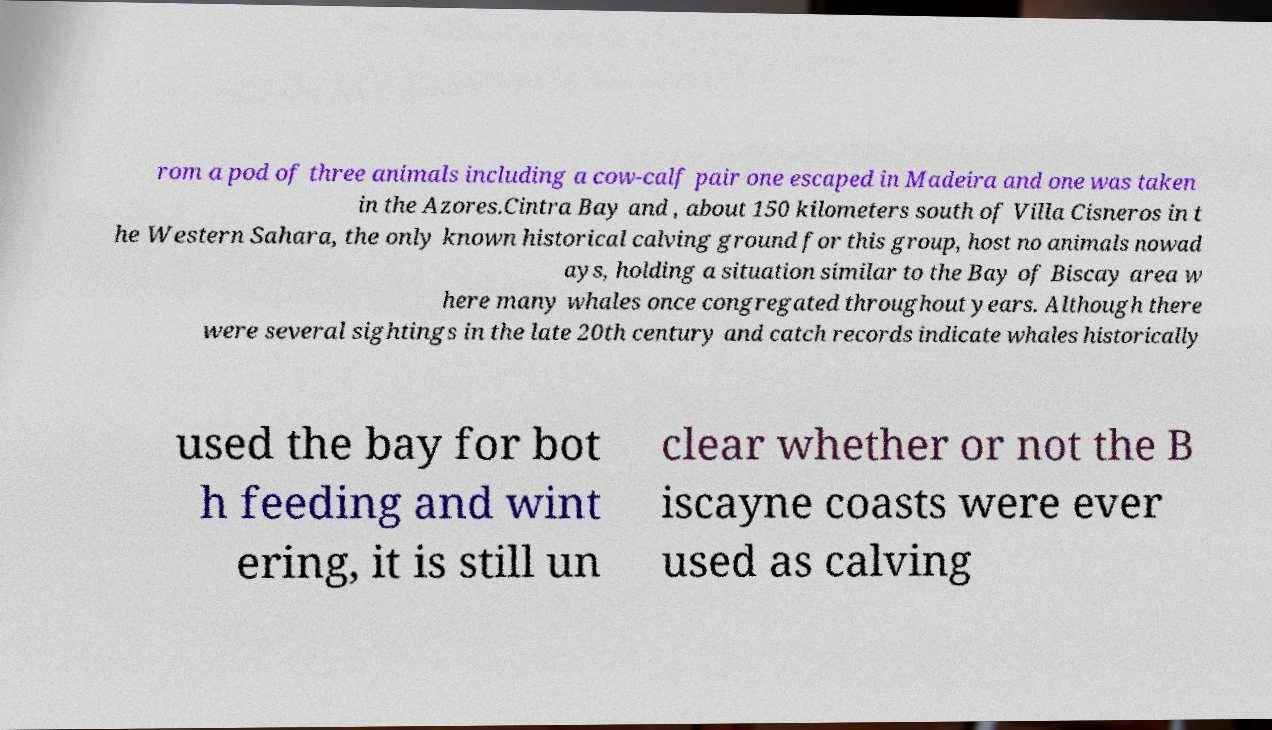Can you read and provide the text displayed in the image?This photo seems to have some interesting text. Can you extract and type it out for me? rom a pod of three animals including a cow-calf pair one escaped in Madeira and one was taken in the Azores.Cintra Bay and , about 150 kilometers south of Villa Cisneros in t he Western Sahara, the only known historical calving ground for this group, host no animals nowad ays, holding a situation similar to the Bay of Biscay area w here many whales once congregated throughout years. Although there were several sightings in the late 20th century and catch records indicate whales historically used the bay for bot h feeding and wint ering, it is still un clear whether or not the B iscayne coasts were ever used as calving 